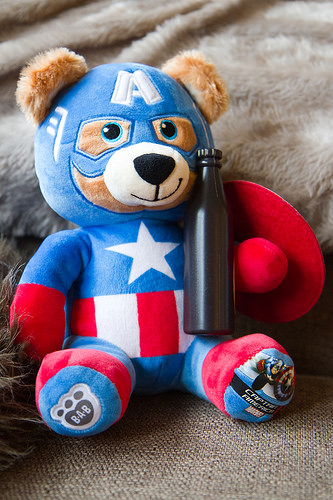<image>
Is the bear in front of the rug? Yes. The bear is positioned in front of the rug, appearing closer to the camera viewpoint. 